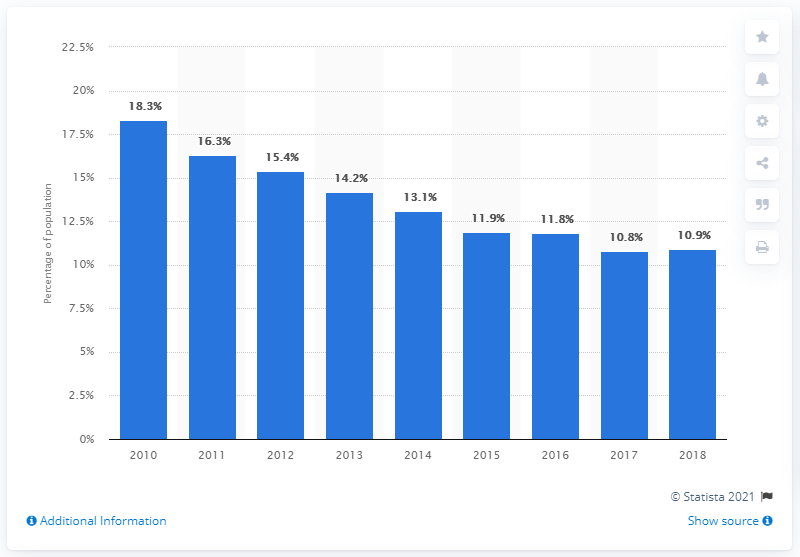Indicate a few pertinent items in this graphic. In 2018, approximately 10.9% of the Colombian population was living on less than $3.20 per day, according to recent data. 